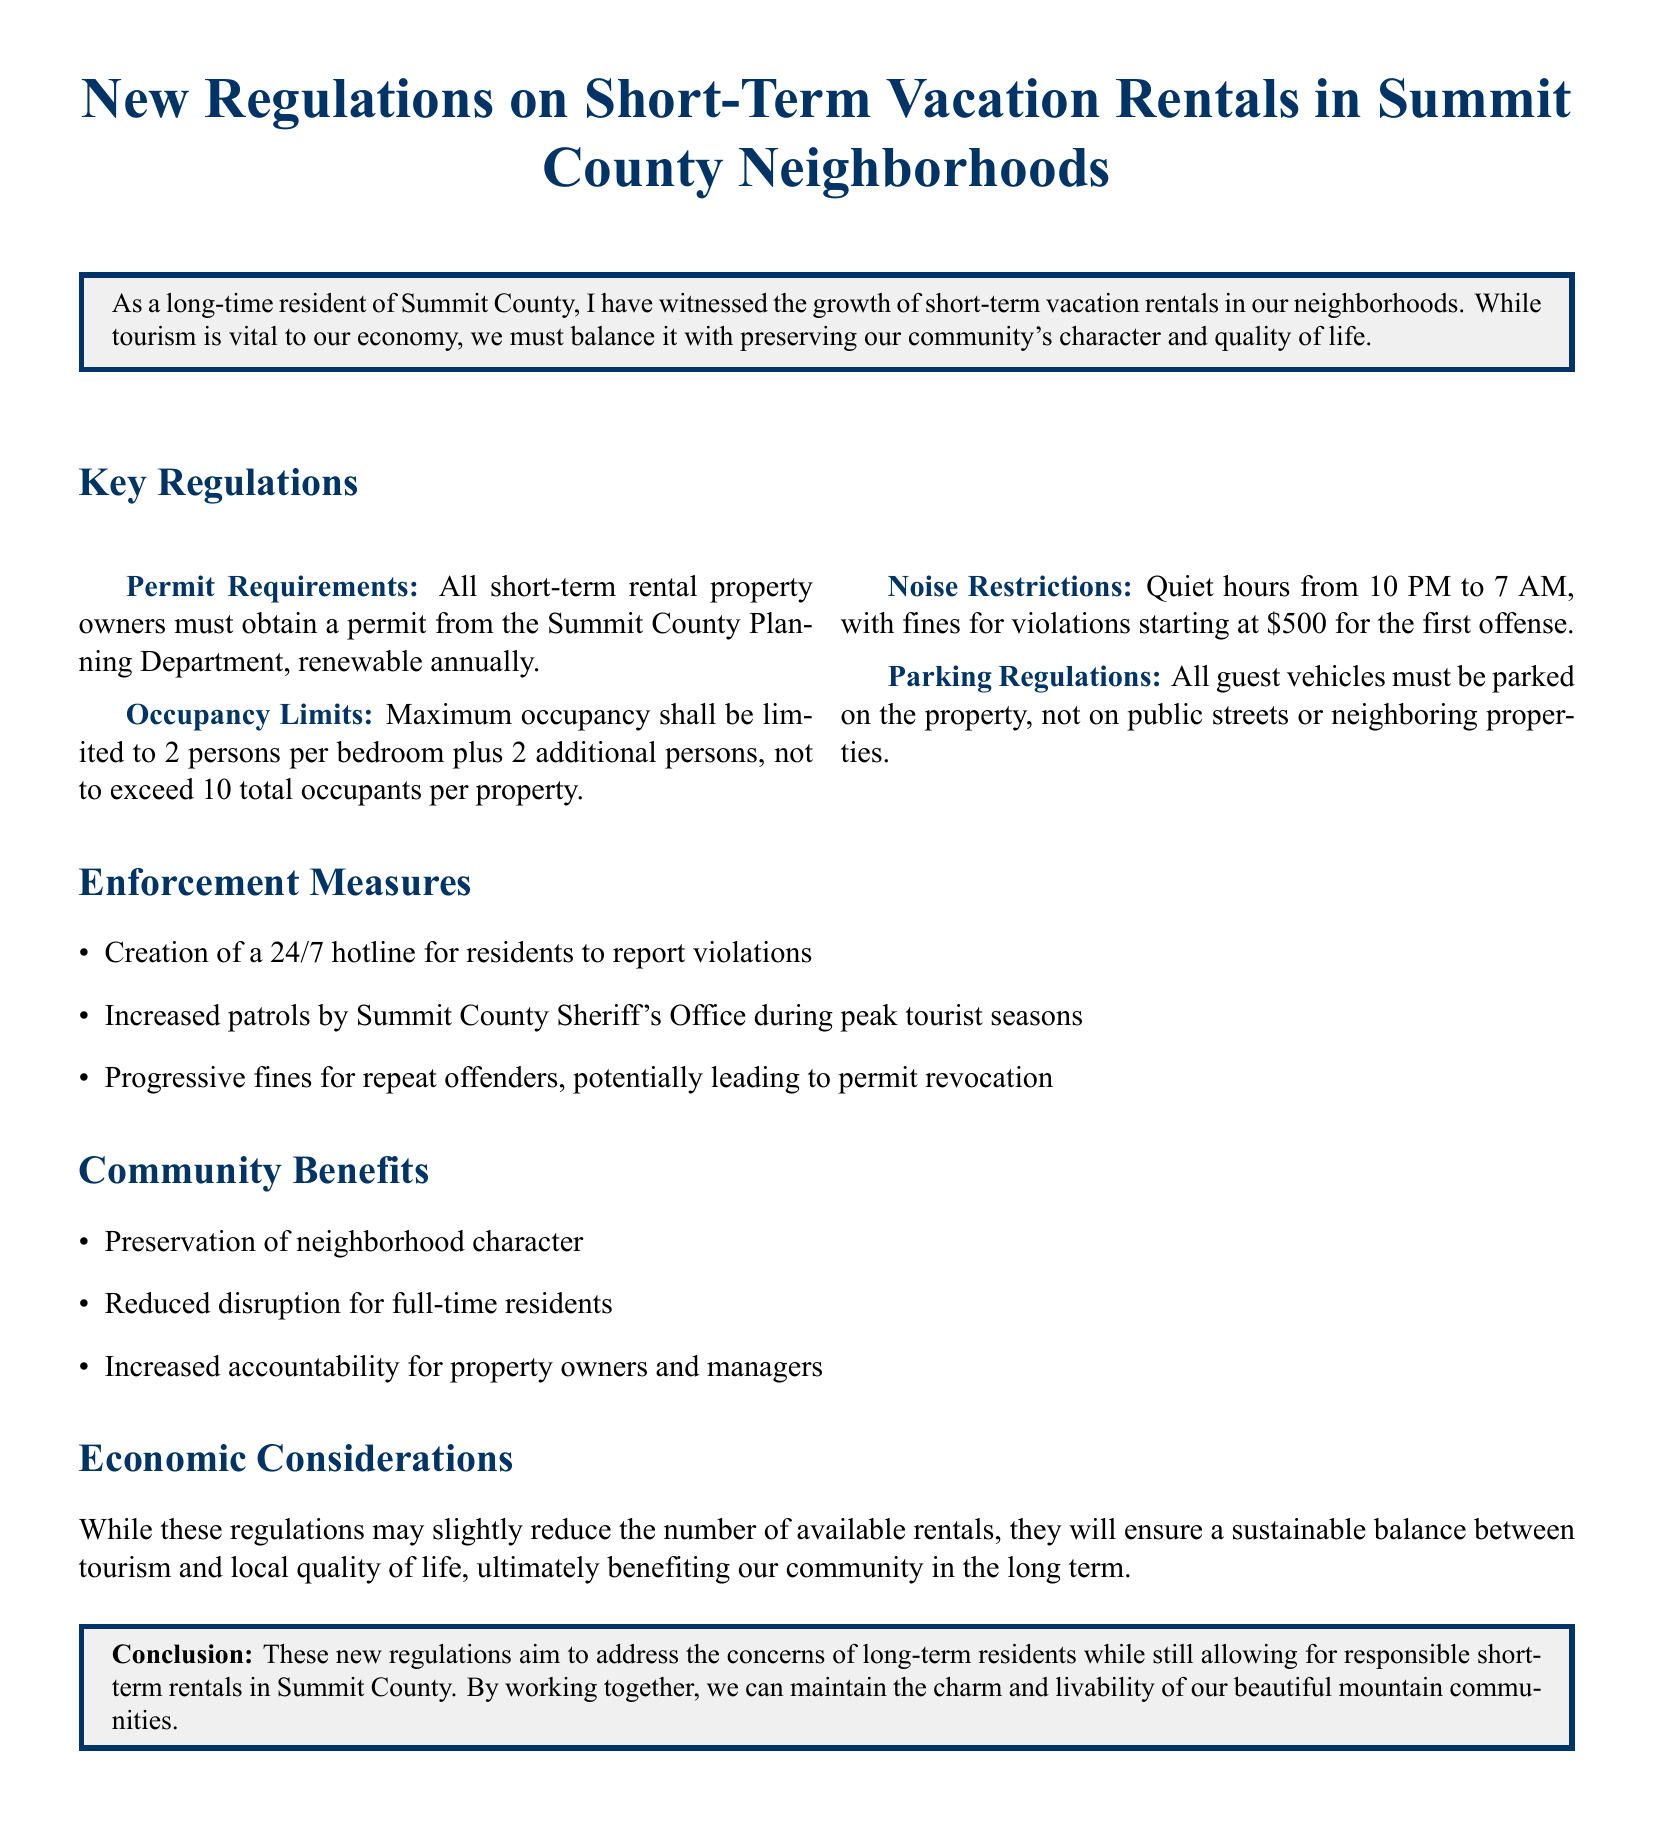What is the annual requirement for short-term rental property owners? All short-term rental property owners must obtain a permit from the Summit County Planning Department, renewable annually.
Answer: renewable annually What is the maximum occupancy limit for a vacation rental? Maximum occupancy shall be limited to 2 persons per bedroom plus 2 additional persons, not to exceed 10 total occupants per property.
Answer: 10 total occupants What are the quiet hours established by the new regulations? Quiet hours from 10 PM to 7 AM, with fines for violations starting at $500 for the first offense.
Answer: 10 PM to 7 AM What is the initial fine for noise violation? Fines for violations starting at $500 for the first offense.
Answer: $500 What will be created to help report violations? Creation of a 24/7 hotline for residents to report violations.
Answer: 24/7 hotline How does the document suggest these regulations will affect tourism? While these regulations may slightly reduce the number of available rentals, they will ensure a sustainable balance between tourism and local quality of life.
Answer: slightly reduce What is one listed community benefit of these regulations? Preservation of neighborhood character.
Answer: Preservation of neighborhood character What is the aim of the new regulations? These new regulations aim to address the concerns of long-term residents while still allowing for responsible short-term rentals in Summit County.
Answer: address the concerns of long-term residents 